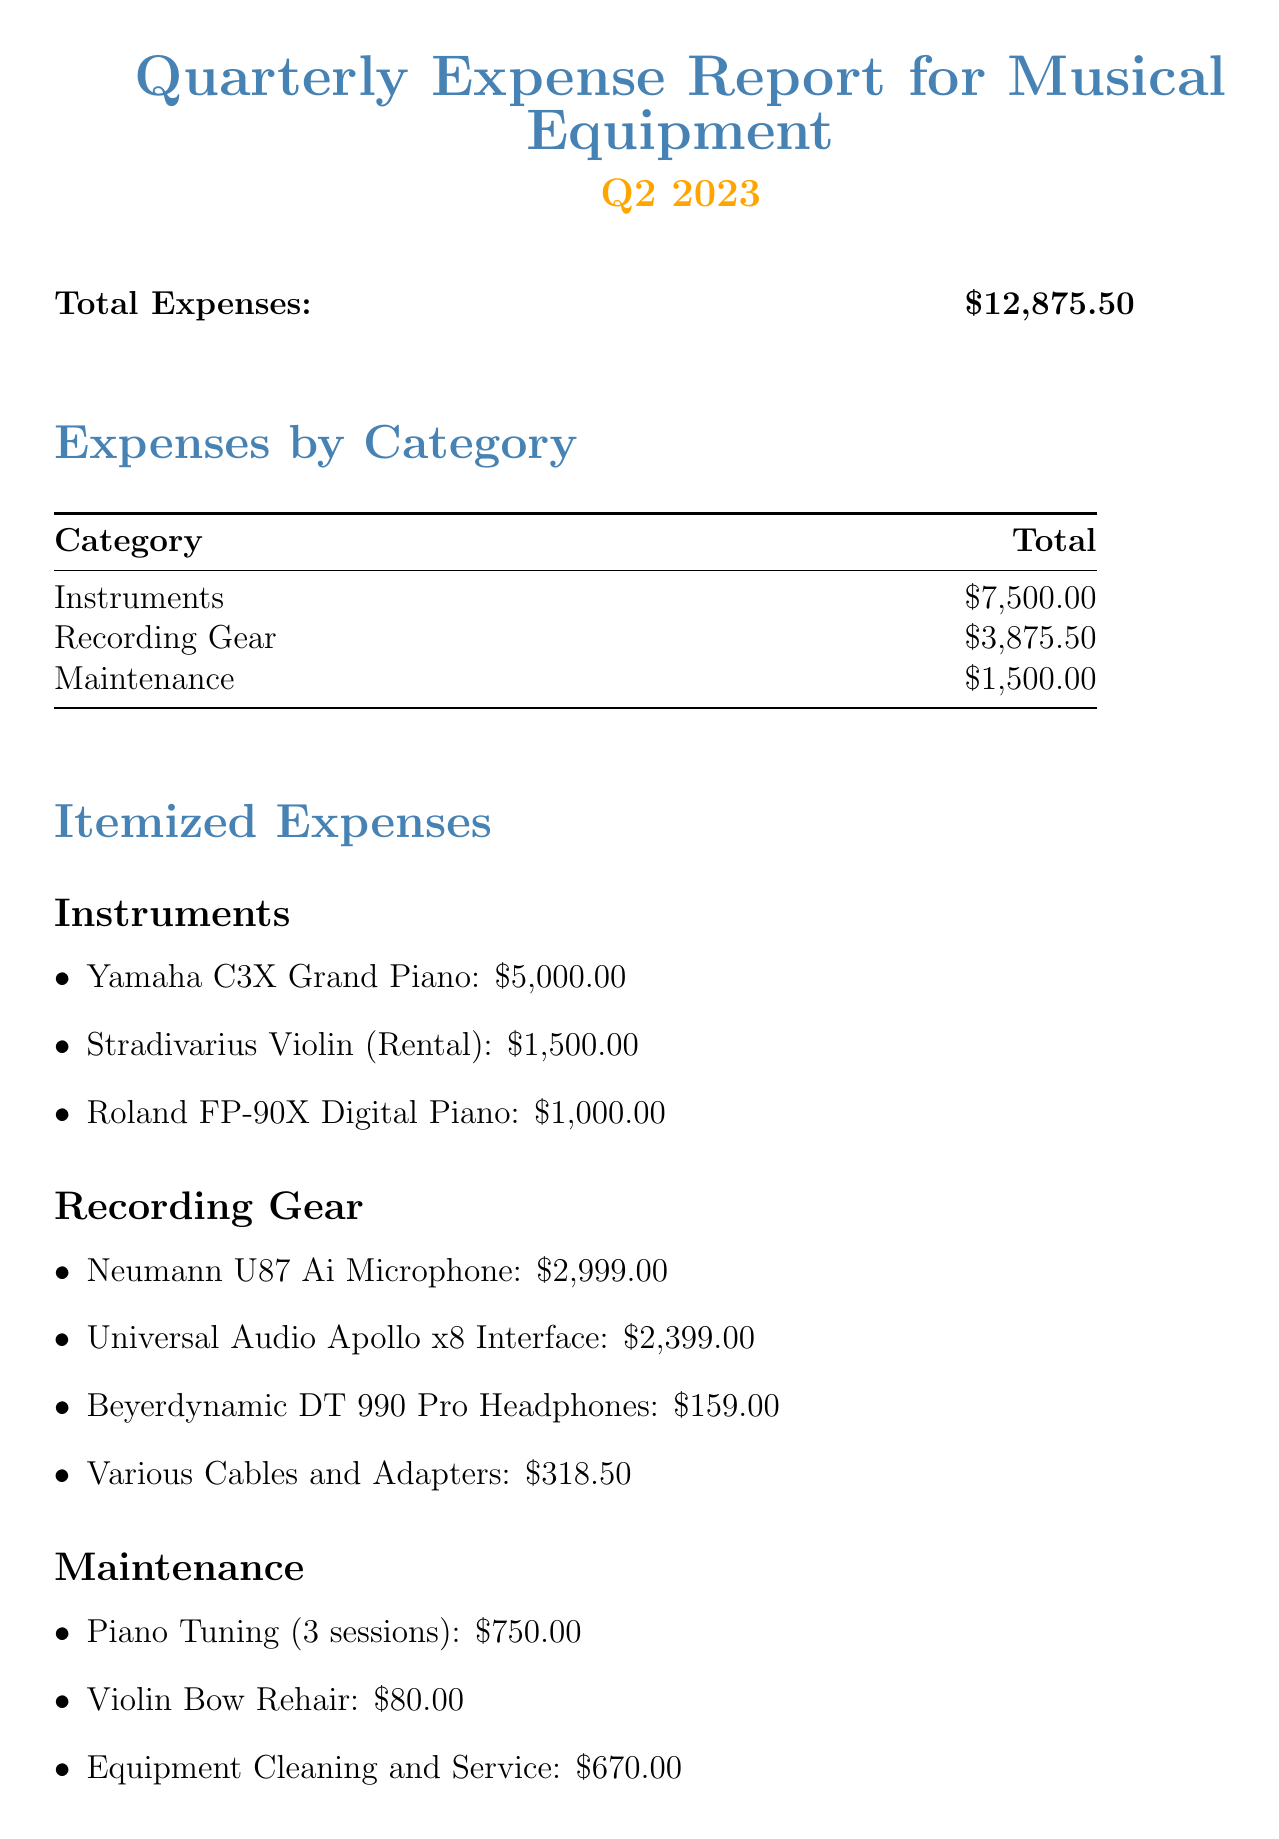What is the total expense for Q2 2023? The total expenses are listed as $12,875.50 in the document.
Answer: $12,875.50 How much was spent on instruments? The category of Instruments shows a total of $7,500.00 in expenses.
Answer: $7,500.00 What is the cost of the Neumann U87 Ai Microphone? The document specifies the cost of the Neumann U87 Ai Microphone as $2,999.00.
Answer: $2,999.00 What item was rented for a special recording project? The Stradivarius Violin is noted as being rented for a special recording project.
Answer: Stradivarius Violin How many sessions of piano tuning were included in the maintenance expenses? The Piano Tuning item mentions a total of 3 sessions included in the expenses.
Answer: 3 sessions What was the total amount spent on maintenance? The total for Maintenance costs in the report is listed as $1,500.00.
Answer: $1,500.00 What percentage of total expenses was allocated to recording gear? The total for Recording Gear is $3,875.50, which makes up approximately 30% of the total expenses.
Answer: 30% What is noted as a reason for increased maintenance costs? The increased maintenance costs are attributed to intensive use in multiple remix projects.
Answer: Intensive use in multiple remix projects How many items were listed under the recording gear category? There are four items included in the Recording Gear category as per the document.
Answer: Four items 